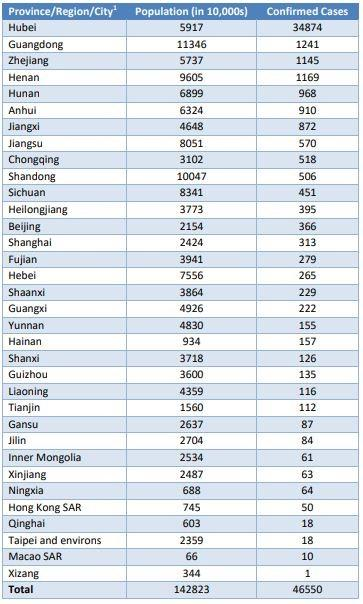Specify some key components in this picture. There are currently 968 confirmed cases of COVID-19 in Hunan. Tibet has reported the least number of confirmed COVID-19 cases in China. The population of Gansu is approximately 26.37 million. The population in 10,000s of Sichuan is 8341. Hubei has reported the highest number of confirmed COVID-19 cases among Chinese provinces. 